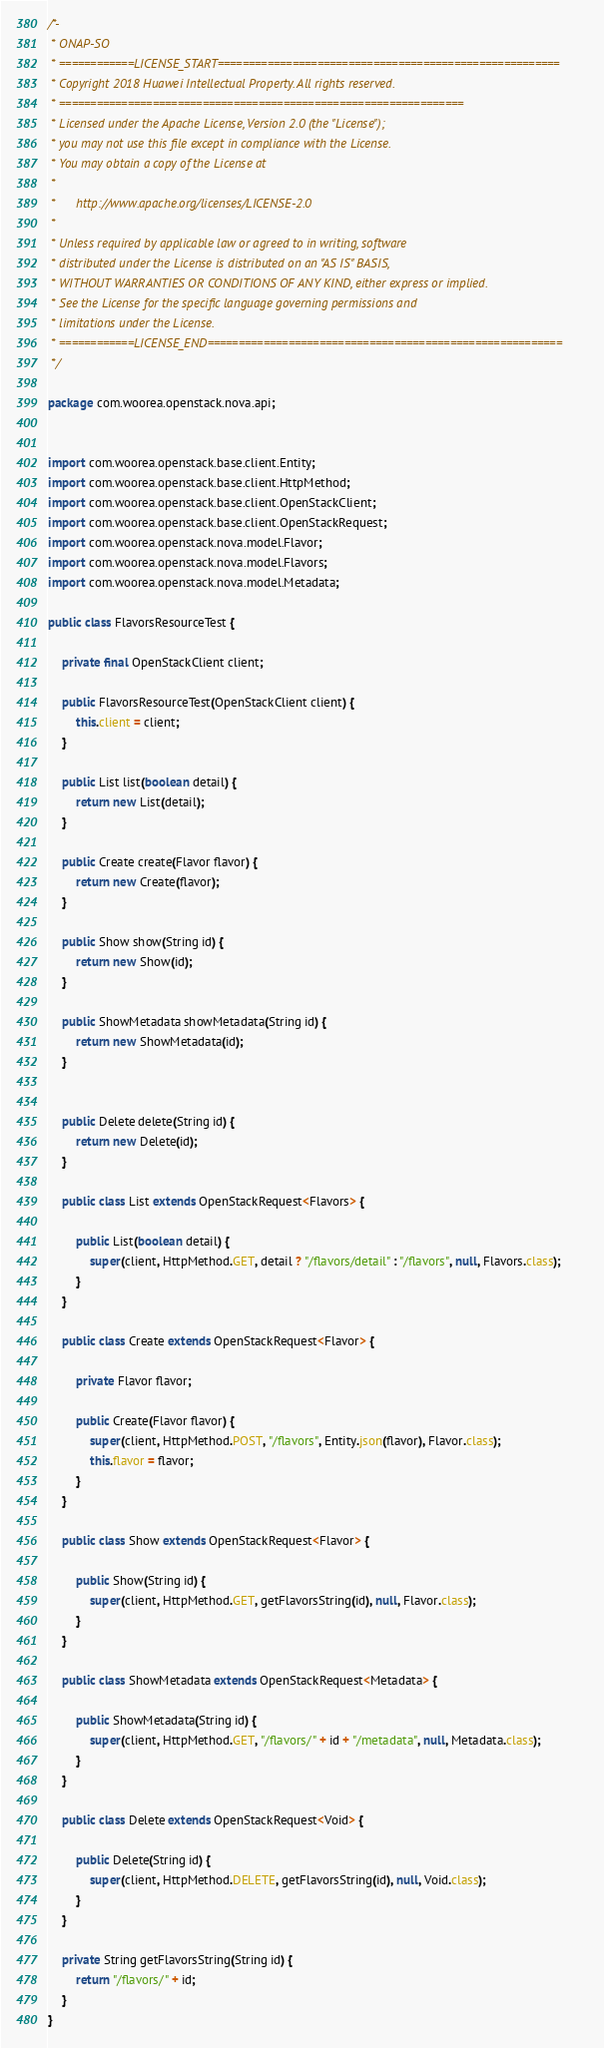<code> <loc_0><loc_0><loc_500><loc_500><_Java_>/*-
 * ONAP-SO
 * ============LICENSE_START=======================================================
 * Copyright 2018 Huawei Intellectual Property. All rights reserved.
 * =================================================================
 * Licensed under the Apache License, Version 2.0 (the "License");
 * you may not use this file except in compliance with the License.
 * You may obtain a copy of the License at
 *
 *      http://www.apache.org/licenses/LICENSE-2.0
 *
 * Unless required by applicable law or agreed to in writing, software
 * distributed under the License is distributed on an "AS IS" BASIS,
 * WITHOUT WARRANTIES OR CONDITIONS OF ANY KIND, either express or implied.
 * See the License for the specific language governing permissions and
 * limitations under the License.
 * ============LICENSE_END=========================================================
 */

package com.woorea.openstack.nova.api;


import com.woorea.openstack.base.client.Entity;
import com.woorea.openstack.base.client.HttpMethod;
import com.woorea.openstack.base.client.OpenStackClient;
import com.woorea.openstack.base.client.OpenStackRequest;
import com.woorea.openstack.nova.model.Flavor;
import com.woorea.openstack.nova.model.Flavors;
import com.woorea.openstack.nova.model.Metadata;

public class FlavorsResourceTest {

    private final OpenStackClient client;

    public FlavorsResourceTest(OpenStackClient client) {
        this.client = client;
    }

    public List list(boolean detail) {
        return new List(detail);
    }

    public Create create(Flavor flavor) {
        return new Create(flavor);
    }

    public Show show(String id) {
        return new Show(id);
    }

    public ShowMetadata showMetadata(String id) {
        return new ShowMetadata(id);
    }


    public Delete delete(String id) {
        return new Delete(id);
    }

    public class List extends OpenStackRequest<Flavors> {

        public List(boolean detail) {
            super(client, HttpMethod.GET, detail ? "/flavors/detail" : "/flavors", null, Flavors.class);
        }
    }

    public class Create extends OpenStackRequest<Flavor> {

        private Flavor flavor;

        public Create(Flavor flavor) {
            super(client, HttpMethod.POST, "/flavors", Entity.json(flavor), Flavor.class);
            this.flavor = flavor;
        }
    }

    public class Show extends OpenStackRequest<Flavor> {

        public Show(String id) {
            super(client, HttpMethod.GET, getFlavorsString(id), null, Flavor.class);
        }
    }

    public class ShowMetadata extends OpenStackRequest<Metadata> {

        public ShowMetadata(String id) {
            super(client, HttpMethod.GET, "/flavors/" + id + "/metadata", null, Metadata.class);
        }
    }

    public class Delete extends OpenStackRequest<Void> {

        public Delete(String id) {
            super(client, HttpMethod.DELETE, getFlavorsString(id), null, Void.class);
        }
    }

    private String getFlavorsString(String id) {
        return "/flavors/" + id;
    }
}

</code> 